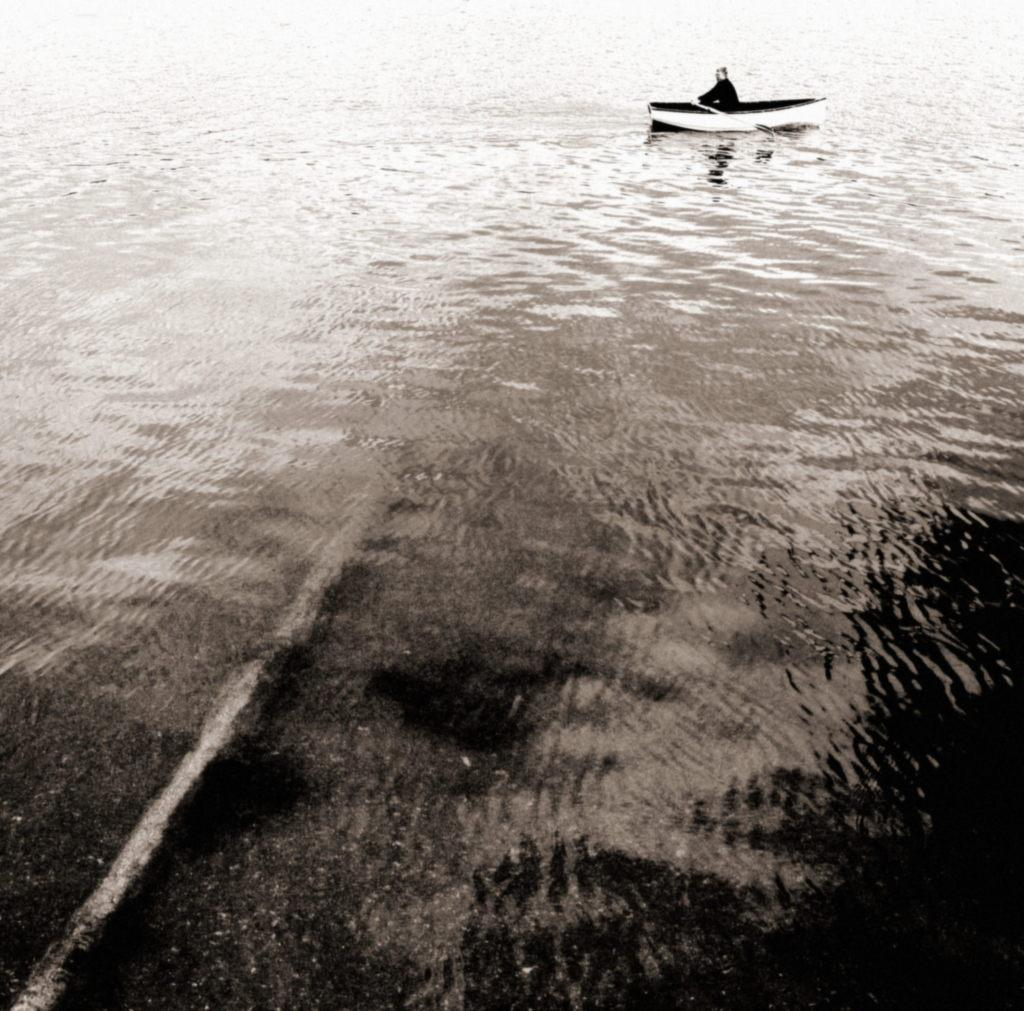What is the primary element in the image? There is water in the image. What is on the water in the image? There is a boat on the water. Who is in the boat in the image? There is a person sitting in the boat. How many children are holding toothbrushes in the image? There are no children or toothbrushes present in the image. 